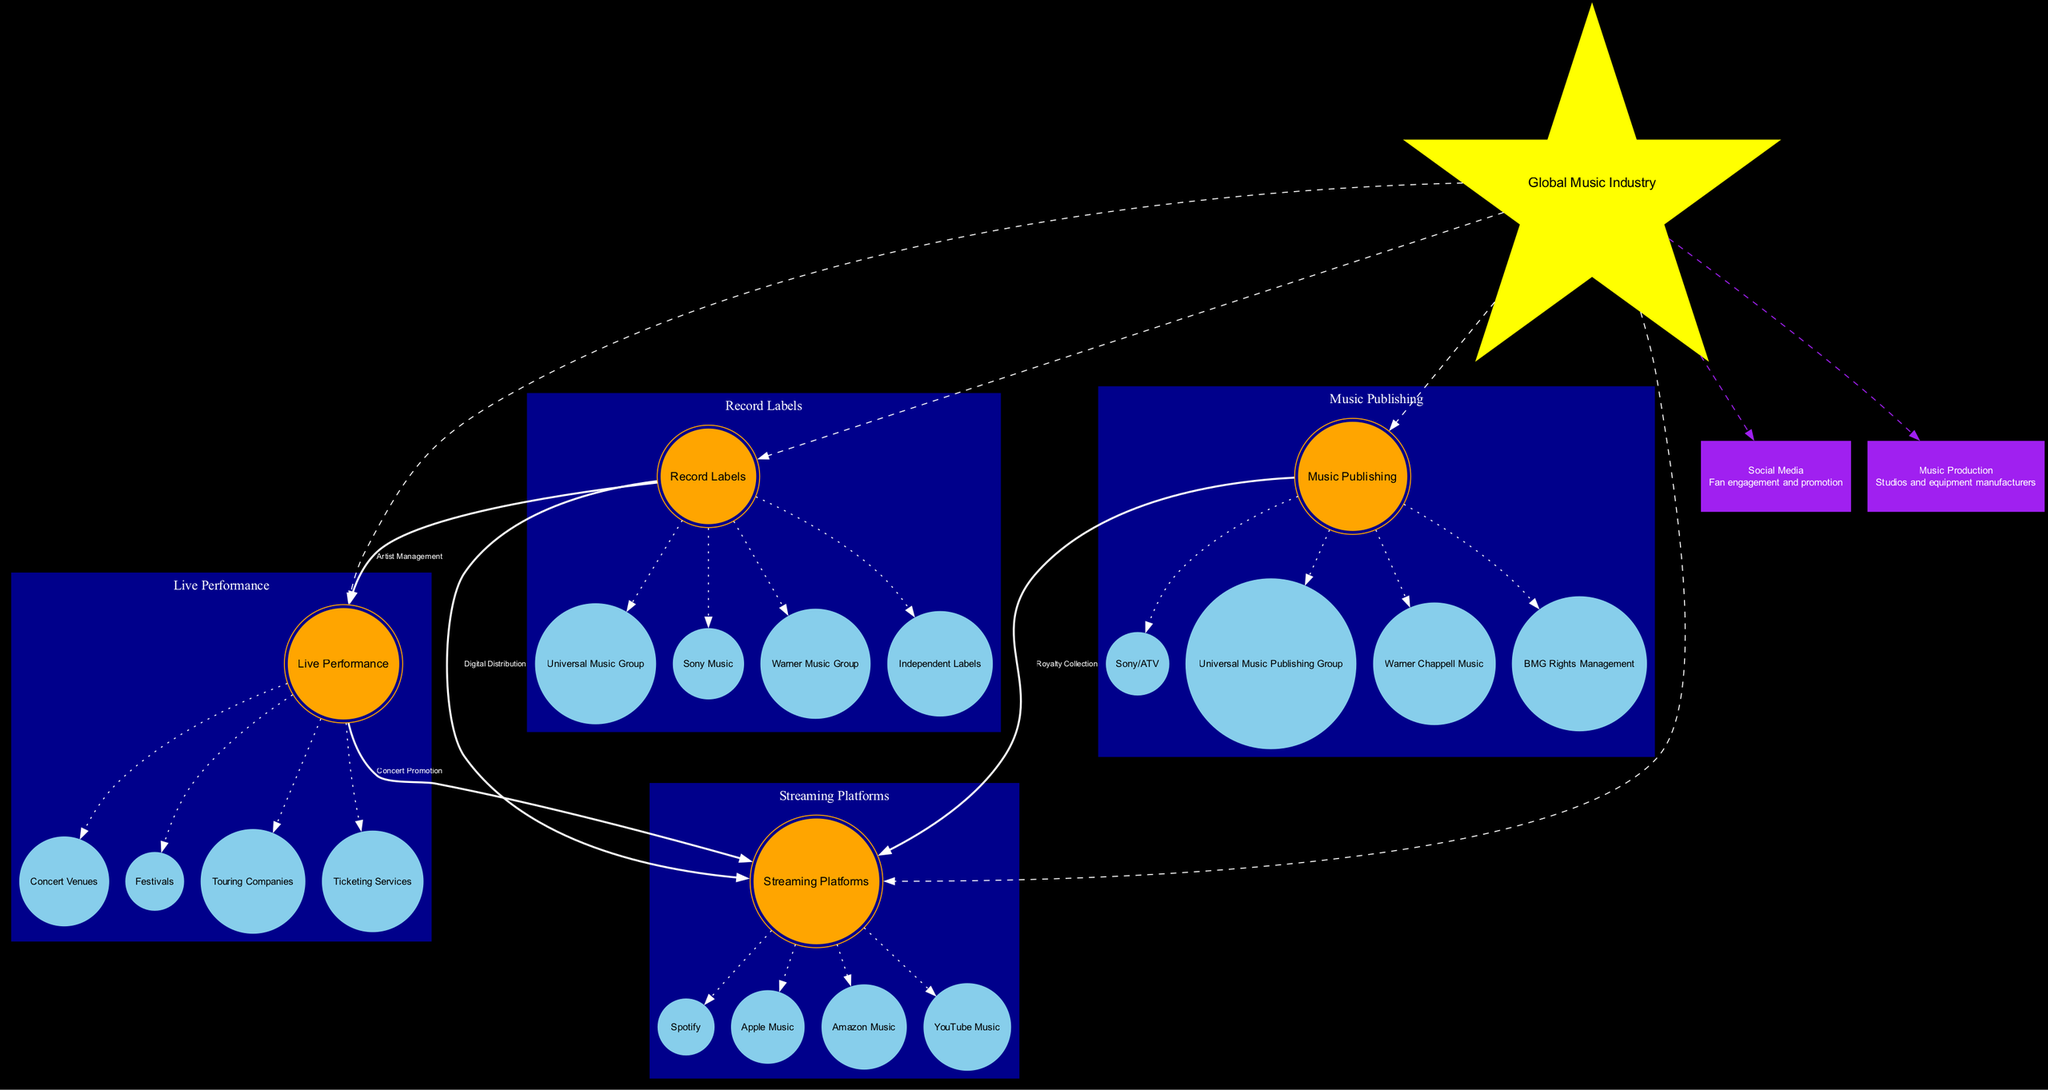What is the central star in this diagram? The central star is labeled as 'Global Music Industry'. It is the main node from which all other elements in the diagram radiate.
Answer: Global Music Industry How many major galaxies are there? The diagram lists four major galaxies: Record Labels, Streaming Platforms, Live Performance, and Music Publishing. By counting each major galaxy, we find there are four in total.
Answer: 4 Which star belongs to the Music Publishing cluster? Within the Music Publishing cluster, 'Sony/ATV' is one of the stars listed. By checking the cluster's information, we identify this star as belonging to that group.
Answer: Sony/ATV What type of relationship connects Record Labels and Streaming Platforms? The relationship between Record Labels and Streaming Platforms is indicated as 'Digital Distribution'. This is a direct connection labeled accordingly in the diagram.
Answer: Digital Distribution How many connections are shown in total? By reviewing the connections illustrated in the diagram, we find there are four distinct connections. Counting them confirms this total.
Answer: 4 What color represents the nebulae in the diagram? The nebulae in the diagram are depicted in the color purple. This visual cue differentiates the nebulae from the other elements, aiding in easy identification.
Answer: Purple Which nebula is associated with fan engagement? The nebula named 'Social Media' is linked with fan engagement and promotion based on the description provided next to it. This association points out its significance in the ecosystem illustrated.
Answer: Social Media How are Live Performance and Streaming Platforms related? The Live Performance and Streaming Platforms are connected through the relationship labeled 'Concert Promotion'. This indicates a collaborative link focused on promoting concerts.
Answer: Concert Promotion What are the stars within the Streaming Platforms cluster? The stars within the Streaming Platforms cluster include Spotify, Apple Music, Amazon Music, and YouTube Music. Listing these out provides a clear view of what constitutes this cluster.
Answer: Spotify, Apple Music, Amazon Music, YouTube Music 